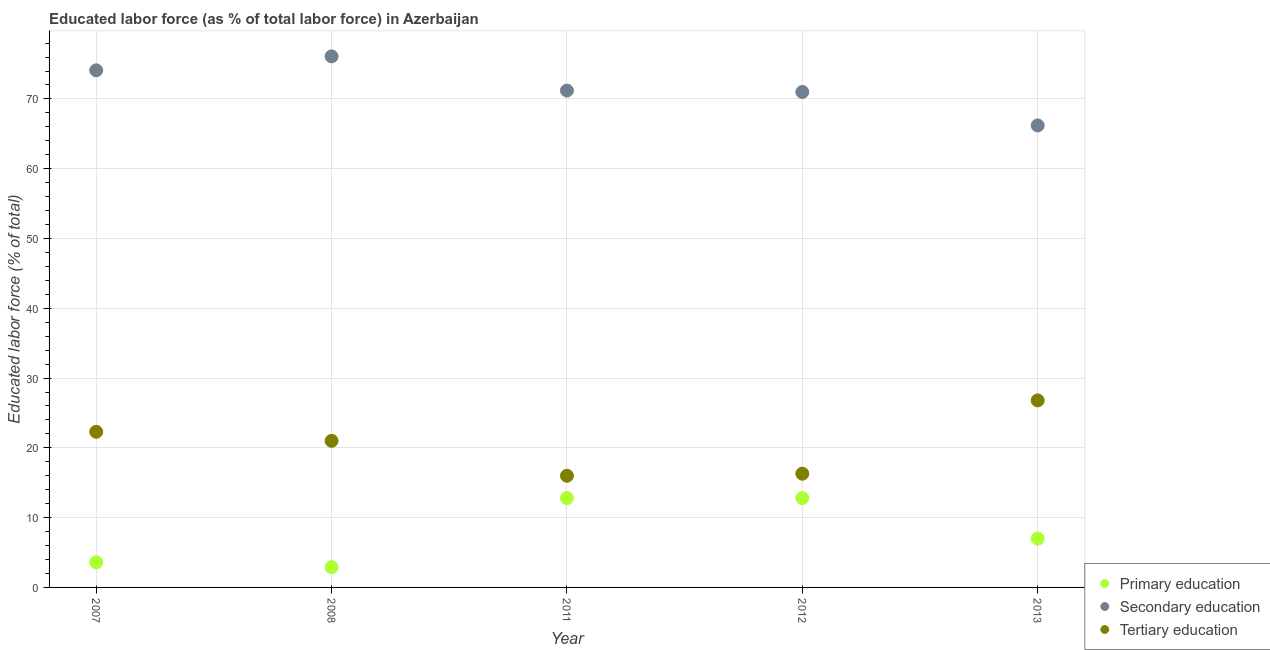How many different coloured dotlines are there?
Offer a very short reply. 3. Is the number of dotlines equal to the number of legend labels?
Provide a succinct answer. Yes. What is the percentage of labor force who received secondary education in 2011?
Make the answer very short. 71.2. Across all years, what is the maximum percentage of labor force who received primary education?
Make the answer very short. 12.8. In which year was the percentage of labor force who received primary education minimum?
Make the answer very short. 2008. What is the total percentage of labor force who received primary education in the graph?
Ensure brevity in your answer.  39.1. What is the difference between the percentage of labor force who received tertiary education in 2011 and that in 2012?
Your response must be concise. -0.3. What is the difference between the percentage of labor force who received tertiary education in 2007 and the percentage of labor force who received primary education in 2013?
Keep it short and to the point. 15.3. What is the average percentage of labor force who received secondary education per year?
Offer a terse response. 71.72. In the year 2008, what is the difference between the percentage of labor force who received tertiary education and percentage of labor force who received primary education?
Your answer should be very brief. 18.1. What is the ratio of the percentage of labor force who received secondary education in 2011 to that in 2012?
Offer a very short reply. 1. Is the percentage of labor force who received secondary education in 2008 less than that in 2013?
Provide a succinct answer. No. What is the difference between the highest and the second highest percentage of labor force who received primary education?
Provide a short and direct response. 0. What is the difference between the highest and the lowest percentage of labor force who received primary education?
Ensure brevity in your answer.  9.9. Is it the case that in every year, the sum of the percentage of labor force who received primary education and percentage of labor force who received secondary education is greater than the percentage of labor force who received tertiary education?
Your response must be concise. Yes. Does the percentage of labor force who received primary education monotonically increase over the years?
Keep it short and to the point. No. How many years are there in the graph?
Your answer should be very brief. 5. Where does the legend appear in the graph?
Ensure brevity in your answer.  Bottom right. What is the title of the graph?
Keep it short and to the point. Educated labor force (as % of total labor force) in Azerbaijan. Does "Social Protection and Labor" appear as one of the legend labels in the graph?
Offer a very short reply. No. What is the label or title of the X-axis?
Provide a short and direct response. Year. What is the label or title of the Y-axis?
Keep it short and to the point. Educated labor force (% of total). What is the Educated labor force (% of total) of Primary education in 2007?
Offer a very short reply. 3.6. What is the Educated labor force (% of total) of Secondary education in 2007?
Ensure brevity in your answer.  74.1. What is the Educated labor force (% of total) in Tertiary education in 2007?
Ensure brevity in your answer.  22.3. What is the Educated labor force (% of total) of Primary education in 2008?
Your answer should be very brief. 2.9. What is the Educated labor force (% of total) in Secondary education in 2008?
Make the answer very short. 76.1. What is the Educated labor force (% of total) in Tertiary education in 2008?
Make the answer very short. 21. What is the Educated labor force (% of total) in Primary education in 2011?
Ensure brevity in your answer.  12.8. What is the Educated labor force (% of total) of Secondary education in 2011?
Your answer should be compact. 71.2. What is the Educated labor force (% of total) of Tertiary education in 2011?
Make the answer very short. 16. What is the Educated labor force (% of total) of Primary education in 2012?
Provide a short and direct response. 12.8. What is the Educated labor force (% of total) of Secondary education in 2012?
Keep it short and to the point. 71. What is the Educated labor force (% of total) in Tertiary education in 2012?
Make the answer very short. 16.3. What is the Educated labor force (% of total) in Secondary education in 2013?
Your answer should be very brief. 66.2. What is the Educated labor force (% of total) of Tertiary education in 2013?
Provide a succinct answer. 26.8. Across all years, what is the maximum Educated labor force (% of total) of Primary education?
Provide a short and direct response. 12.8. Across all years, what is the maximum Educated labor force (% of total) of Secondary education?
Provide a short and direct response. 76.1. Across all years, what is the maximum Educated labor force (% of total) of Tertiary education?
Make the answer very short. 26.8. Across all years, what is the minimum Educated labor force (% of total) in Primary education?
Your answer should be compact. 2.9. Across all years, what is the minimum Educated labor force (% of total) of Secondary education?
Your answer should be very brief. 66.2. What is the total Educated labor force (% of total) in Primary education in the graph?
Give a very brief answer. 39.1. What is the total Educated labor force (% of total) of Secondary education in the graph?
Offer a terse response. 358.6. What is the total Educated labor force (% of total) in Tertiary education in the graph?
Your answer should be very brief. 102.4. What is the difference between the Educated labor force (% of total) in Primary education in 2007 and that in 2008?
Ensure brevity in your answer.  0.7. What is the difference between the Educated labor force (% of total) in Secondary education in 2007 and that in 2008?
Your answer should be very brief. -2. What is the difference between the Educated labor force (% of total) in Primary education in 2007 and that in 2011?
Provide a short and direct response. -9.2. What is the difference between the Educated labor force (% of total) in Tertiary education in 2007 and that in 2011?
Offer a terse response. 6.3. What is the difference between the Educated labor force (% of total) of Primary education in 2007 and that in 2012?
Provide a succinct answer. -9.2. What is the difference between the Educated labor force (% of total) in Tertiary education in 2007 and that in 2012?
Offer a very short reply. 6. What is the difference between the Educated labor force (% of total) of Primary education in 2007 and that in 2013?
Give a very brief answer. -3.4. What is the difference between the Educated labor force (% of total) of Tertiary education in 2007 and that in 2013?
Keep it short and to the point. -4.5. What is the difference between the Educated labor force (% of total) in Primary education in 2008 and that in 2011?
Provide a short and direct response. -9.9. What is the difference between the Educated labor force (% of total) in Primary education in 2008 and that in 2012?
Your answer should be very brief. -9.9. What is the difference between the Educated labor force (% of total) of Secondary education in 2008 and that in 2012?
Your response must be concise. 5.1. What is the difference between the Educated labor force (% of total) of Primary education in 2011 and that in 2012?
Your response must be concise. 0. What is the difference between the Educated labor force (% of total) in Secondary education in 2011 and that in 2013?
Offer a terse response. 5. What is the difference between the Educated labor force (% of total) of Tertiary education in 2011 and that in 2013?
Offer a very short reply. -10.8. What is the difference between the Educated labor force (% of total) of Tertiary education in 2012 and that in 2013?
Your answer should be compact. -10.5. What is the difference between the Educated labor force (% of total) of Primary education in 2007 and the Educated labor force (% of total) of Secondary education in 2008?
Your answer should be compact. -72.5. What is the difference between the Educated labor force (% of total) in Primary education in 2007 and the Educated labor force (% of total) in Tertiary education in 2008?
Provide a short and direct response. -17.4. What is the difference between the Educated labor force (% of total) in Secondary education in 2007 and the Educated labor force (% of total) in Tertiary education in 2008?
Provide a succinct answer. 53.1. What is the difference between the Educated labor force (% of total) in Primary education in 2007 and the Educated labor force (% of total) in Secondary education in 2011?
Your answer should be very brief. -67.6. What is the difference between the Educated labor force (% of total) in Primary education in 2007 and the Educated labor force (% of total) in Tertiary education in 2011?
Provide a succinct answer. -12.4. What is the difference between the Educated labor force (% of total) of Secondary education in 2007 and the Educated labor force (% of total) of Tertiary education in 2011?
Offer a very short reply. 58.1. What is the difference between the Educated labor force (% of total) in Primary education in 2007 and the Educated labor force (% of total) in Secondary education in 2012?
Your response must be concise. -67.4. What is the difference between the Educated labor force (% of total) in Secondary education in 2007 and the Educated labor force (% of total) in Tertiary education in 2012?
Your answer should be compact. 57.8. What is the difference between the Educated labor force (% of total) of Primary education in 2007 and the Educated labor force (% of total) of Secondary education in 2013?
Offer a terse response. -62.6. What is the difference between the Educated labor force (% of total) of Primary education in 2007 and the Educated labor force (% of total) of Tertiary education in 2013?
Give a very brief answer. -23.2. What is the difference between the Educated labor force (% of total) of Secondary education in 2007 and the Educated labor force (% of total) of Tertiary education in 2013?
Provide a succinct answer. 47.3. What is the difference between the Educated labor force (% of total) of Primary education in 2008 and the Educated labor force (% of total) of Secondary education in 2011?
Make the answer very short. -68.3. What is the difference between the Educated labor force (% of total) in Secondary education in 2008 and the Educated labor force (% of total) in Tertiary education in 2011?
Offer a very short reply. 60.1. What is the difference between the Educated labor force (% of total) of Primary education in 2008 and the Educated labor force (% of total) of Secondary education in 2012?
Provide a succinct answer. -68.1. What is the difference between the Educated labor force (% of total) in Primary education in 2008 and the Educated labor force (% of total) in Tertiary education in 2012?
Provide a succinct answer. -13.4. What is the difference between the Educated labor force (% of total) of Secondary education in 2008 and the Educated labor force (% of total) of Tertiary education in 2012?
Offer a terse response. 59.8. What is the difference between the Educated labor force (% of total) in Primary education in 2008 and the Educated labor force (% of total) in Secondary education in 2013?
Keep it short and to the point. -63.3. What is the difference between the Educated labor force (% of total) in Primary education in 2008 and the Educated labor force (% of total) in Tertiary education in 2013?
Provide a succinct answer. -23.9. What is the difference between the Educated labor force (% of total) in Secondary education in 2008 and the Educated labor force (% of total) in Tertiary education in 2013?
Ensure brevity in your answer.  49.3. What is the difference between the Educated labor force (% of total) in Primary education in 2011 and the Educated labor force (% of total) in Secondary education in 2012?
Keep it short and to the point. -58.2. What is the difference between the Educated labor force (% of total) of Secondary education in 2011 and the Educated labor force (% of total) of Tertiary education in 2012?
Provide a short and direct response. 54.9. What is the difference between the Educated labor force (% of total) of Primary education in 2011 and the Educated labor force (% of total) of Secondary education in 2013?
Keep it short and to the point. -53.4. What is the difference between the Educated labor force (% of total) in Primary education in 2011 and the Educated labor force (% of total) in Tertiary education in 2013?
Your answer should be compact. -14. What is the difference between the Educated labor force (% of total) of Secondary education in 2011 and the Educated labor force (% of total) of Tertiary education in 2013?
Ensure brevity in your answer.  44.4. What is the difference between the Educated labor force (% of total) of Primary education in 2012 and the Educated labor force (% of total) of Secondary education in 2013?
Ensure brevity in your answer.  -53.4. What is the difference between the Educated labor force (% of total) of Primary education in 2012 and the Educated labor force (% of total) of Tertiary education in 2013?
Ensure brevity in your answer.  -14. What is the difference between the Educated labor force (% of total) of Secondary education in 2012 and the Educated labor force (% of total) of Tertiary education in 2013?
Keep it short and to the point. 44.2. What is the average Educated labor force (% of total) in Primary education per year?
Your answer should be compact. 7.82. What is the average Educated labor force (% of total) in Secondary education per year?
Your answer should be compact. 71.72. What is the average Educated labor force (% of total) in Tertiary education per year?
Give a very brief answer. 20.48. In the year 2007, what is the difference between the Educated labor force (% of total) in Primary education and Educated labor force (% of total) in Secondary education?
Offer a very short reply. -70.5. In the year 2007, what is the difference between the Educated labor force (% of total) in Primary education and Educated labor force (% of total) in Tertiary education?
Offer a terse response. -18.7. In the year 2007, what is the difference between the Educated labor force (% of total) of Secondary education and Educated labor force (% of total) of Tertiary education?
Offer a terse response. 51.8. In the year 2008, what is the difference between the Educated labor force (% of total) of Primary education and Educated labor force (% of total) of Secondary education?
Your response must be concise. -73.2. In the year 2008, what is the difference between the Educated labor force (% of total) in Primary education and Educated labor force (% of total) in Tertiary education?
Ensure brevity in your answer.  -18.1. In the year 2008, what is the difference between the Educated labor force (% of total) in Secondary education and Educated labor force (% of total) in Tertiary education?
Provide a succinct answer. 55.1. In the year 2011, what is the difference between the Educated labor force (% of total) of Primary education and Educated labor force (% of total) of Secondary education?
Your answer should be very brief. -58.4. In the year 2011, what is the difference between the Educated labor force (% of total) of Secondary education and Educated labor force (% of total) of Tertiary education?
Your response must be concise. 55.2. In the year 2012, what is the difference between the Educated labor force (% of total) in Primary education and Educated labor force (% of total) in Secondary education?
Give a very brief answer. -58.2. In the year 2012, what is the difference between the Educated labor force (% of total) of Primary education and Educated labor force (% of total) of Tertiary education?
Your answer should be compact. -3.5. In the year 2012, what is the difference between the Educated labor force (% of total) in Secondary education and Educated labor force (% of total) in Tertiary education?
Keep it short and to the point. 54.7. In the year 2013, what is the difference between the Educated labor force (% of total) of Primary education and Educated labor force (% of total) of Secondary education?
Your answer should be very brief. -59.2. In the year 2013, what is the difference between the Educated labor force (% of total) of Primary education and Educated labor force (% of total) of Tertiary education?
Make the answer very short. -19.8. In the year 2013, what is the difference between the Educated labor force (% of total) of Secondary education and Educated labor force (% of total) of Tertiary education?
Keep it short and to the point. 39.4. What is the ratio of the Educated labor force (% of total) in Primary education in 2007 to that in 2008?
Give a very brief answer. 1.24. What is the ratio of the Educated labor force (% of total) of Secondary education in 2007 to that in 2008?
Provide a succinct answer. 0.97. What is the ratio of the Educated labor force (% of total) of Tertiary education in 2007 to that in 2008?
Give a very brief answer. 1.06. What is the ratio of the Educated labor force (% of total) of Primary education in 2007 to that in 2011?
Your answer should be very brief. 0.28. What is the ratio of the Educated labor force (% of total) in Secondary education in 2007 to that in 2011?
Provide a succinct answer. 1.04. What is the ratio of the Educated labor force (% of total) in Tertiary education in 2007 to that in 2011?
Provide a succinct answer. 1.39. What is the ratio of the Educated labor force (% of total) in Primary education in 2007 to that in 2012?
Your response must be concise. 0.28. What is the ratio of the Educated labor force (% of total) of Secondary education in 2007 to that in 2012?
Ensure brevity in your answer.  1.04. What is the ratio of the Educated labor force (% of total) of Tertiary education in 2007 to that in 2012?
Provide a short and direct response. 1.37. What is the ratio of the Educated labor force (% of total) in Primary education in 2007 to that in 2013?
Your answer should be very brief. 0.51. What is the ratio of the Educated labor force (% of total) of Secondary education in 2007 to that in 2013?
Make the answer very short. 1.12. What is the ratio of the Educated labor force (% of total) of Tertiary education in 2007 to that in 2013?
Offer a terse response. 0.83. What is the ratio of the Educated labor force (% of total) of Primary education in 2008 to that in 2011?
Ensure brevity in your answer.  0.23. What is the ratio of the Educated labor force (% of total) of Secondary education in 2008 to that in 2011?
Ensure brevity in your answer.  1.07. What is the ratio of the Educated labor force (% of total) of Tertiary education in 2008 to that in 2011?
Ensure brevity in your answer.  1.31. What is the ratio of the Educated labor force (% of total) of Primary education in 2008 to that in 2012?
Provide a succinct answer. 0.23. What is the ratio of the Educated labor force (% of total) in Secondary education in 2008 to that in 2012?
Provide a short and direct response. 1.07. What is the ratio of the Educated labor force (% of total) in Tertiary education in 2008 to that in 2012?
Your answer should be very brief. 1.29. What is the ratio of the Educated labor force (% of total) of Primary education in 2008 to that in 2013?
Offer a very short reply. 0.41. What is the ratio of the Educated labor force (% of total) of Secondary education in 2008 to that in 2013?
Provide a succinct answer. 1.15. What is the ratio of the Educated labor force (% of total) of Tertiary education in 2008 to that in 2013?
Give a very brief answer. 0.78. What is the ratio of the Educated labor force (% of total) in Primary education in 2011 to that in 2012?
Provide a succinct answer. 1. What is the ratio of the Educated labor force (% of total) in Secondary education in 2011 to that in 2012?
Keep it short and to the point. 1. What is the ratio of the Educated labor force (% of total) of Tertiary education in 2011 to that in 2012?
Your answer should be very brief. 0.98. What is the ratio of the Educated labor force (% of total) of Primary education in 2011 to that in 2013?
Your response must be concise. 1.83. What is the ratio of the Educated labor force (% of total) of Secondary education in 2011 to that in 2013?
Ensure brevity in your answer.  1.08. What is the ratio of the Educated labor force (% of total) of Tertiary education in 2011 to that in 2013?
Give a very brief answer. 0.6. What is the ratio of the Educated labor force (% of total) in Primary education in 2012 to that in 2013?
Your response must be concise. 1.83. What is the ratio of the Educated labor force (% of total) of Secondary education in 2012 to that in 2013?
Ensure brevity in your answer.  1.07. What is the ratio of the Educated labor force (% of total) of Tertiary education in 2012 to that in 2013?
Provide a succinct answer. 0.61. What is the difference between the highest and the second highest Educated labor force (% of total) of Primary education?
Give a very brief answer. 0. What is the difference between the highest and the lowest Educated labor force (% of total) in Primary education?
Provide a short and direct response. 9.9. What is the difference between the highest and the lowest Educated labor force (% of total) in Tertiary education?
Give a very brief answer. 10.8. 